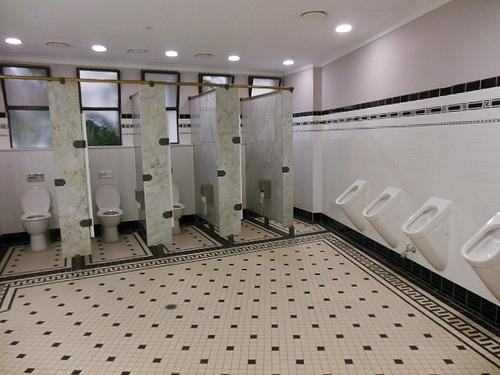Question: where was the picture taken?
Choices:
A. A bathroom.
B. Outside.
C. A bedroom.
D. A kitchen.
Answer with the letter. Answer: A Question: what is covering the floor?
Choices:
A. Hard wood.
B. Tiles.
C. Carpet.
D. Linoleum.
Answer with the letter. Answer: B Question: what color are the tiles?
Choices:
A. Yellow.
B. Blue.
C. Black and white.
D. White & green.
Answer with the letter. Answer: D Question: how many lights can be seen on the ceiling?
Choices:
A. 6.
B. 7.
C. 8.
D. 5.
Answer with the letter. Answer: A Question: where are the urinals attached?
Choices:
A. To the floor.
B. Freestanding.
C. In the corner.
D. On the wall.
Answer with the letter. Answer: D Question: what color are the toilets?
Choices:
A. Black.
B. White.
C. Brown.
D. Beige.
Answer with the letter. Answer: B 